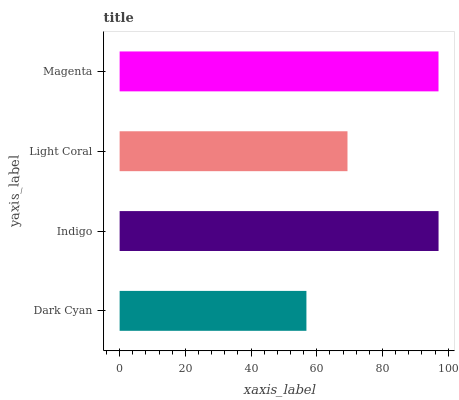Is Dark Cyan the minimum?
Answer yes or no. Yes. Is Indigo the maximum?
Answer yes or no. Yes. Is Light Coral the minimum?
Answer yes or no. No. Is Light Coral the maximum?
Answer yes or no. No. Is Indigo greater than Light Coral?
Answer yes or no. Yes. Is Light Coral less than Indigo?
Answer yes or no. Yes. Is Light Coral greater than Indigo?
Answer yes or no. No. Is Indigo less than Light Coral?
Answer yes or no. No. Is Magenta the high median?
Answer yes or no. Yes. Is Light Coral the low median?
Answer yes or no. Yes. Is Indigo the high median?
Answer yes or no. No. Is Magenta the low median?
Answer yes or no. No. 